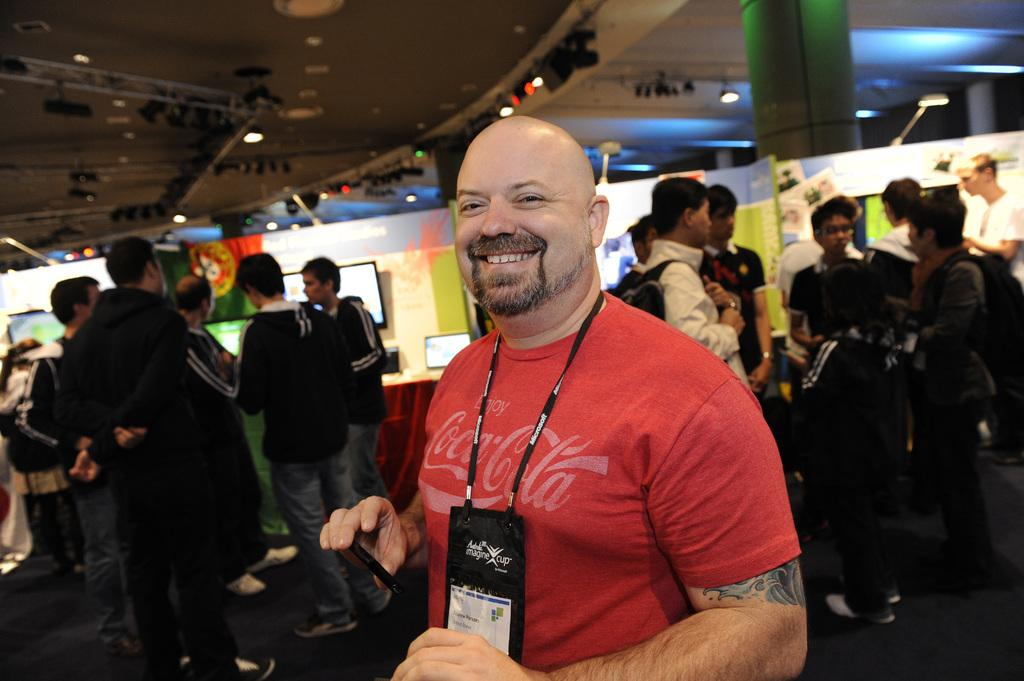What is the main subject in the middle of the image? There is a man standing in the middle of the image. What is the man's facial expression? The man is smiling. What type of clothing is the man wearing? The man is wearing a t-shirt. What can be seen on the left side of the image? There is a group of people standing on the left side of the image. What are the people in the group doing? The group of people are looking in the same direction. What statement did the man make while standing in the middle of the image? There is no statement made by the man in the image; we can only observe his facial expression and clothing. 